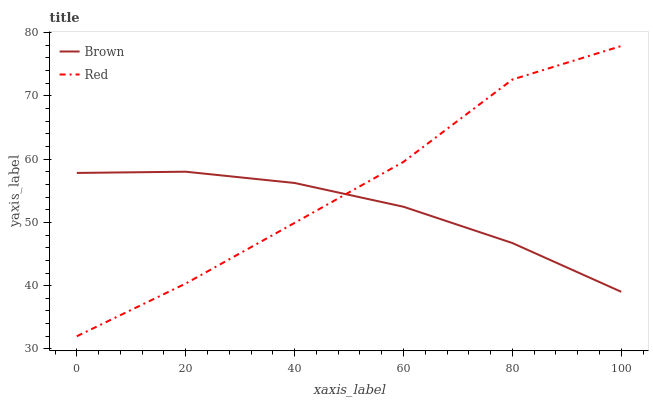Does Brown have the minimum area under the curve?
Answer yes or no. Yes. Does Red have the maximum area under the curve?
Answer yes or no. Yes. Does Red have the minimum area under the curve?
Answer yes or no. No. Is Brown the smoothest?
Answer yes or no. Yes. Is Red the roughest?
Answer yes or no. Yes. Is Red the smoothest?
Answer yes or no. No. Does Red have the lowest value?
Answer yes or no. Yes. Does Red have the highest value?
Answer yes or no. Yes. Does Red intersect Brown?
Answer yes or no. Yes. Is Red less than Brown?
Answer yes or no. No. Is Red greater than Brown?
Answer yes or no. No. 